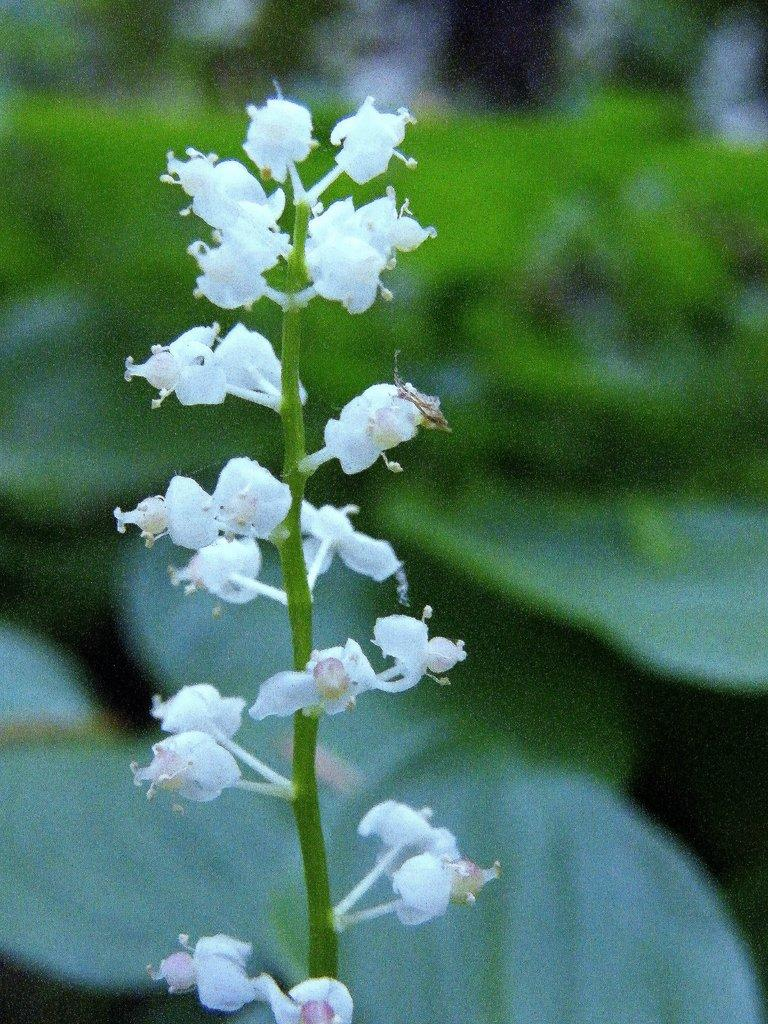What type of plants can be seen in the image? There are flowers in the image. Can you describe the structure of the flowers? The flowers have stems. What type of toothbrush is being used by the donkey in the image? There is no toothbrush or donkey present in the image; it only features flowers with stems. 